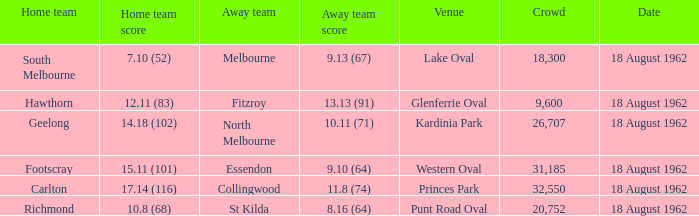Would you mind parsing the complete table? {'header': ['Home team', 'Home team score', 'Away team', 'Away team score', 'Venue', 'Crowd', 'Date'], 'rows': [['South Melbourne', '7.10 (52)', 'Melbourne', '9.13 (67)', 'Lake Oval', '18,300', '18 August 1962'], ['Hawthorn', '12.11 (83)', 'Fitzroy', '13.13 (91)', 'Glenferrie Oval', '9,600', '18 August 1962'], ['Geelong', '14.18 (102)', 'North Melbourne', '10.11 (71)', 'Kardinia Park', '26,707', '18 August 1962'], ['Footscray', '15.11 (101)', 'Essendon', '9.10 (64)', 'Western Oval', '31,185', '18 August 1962'], ['Carlton', '17.14 (116)', 'Collingwood', '11.8 (74)', 'Princes Park', '32,550', '18 August 1962'], ['Richmond', '10.8 (68)', 'St Kilda', '8.16 (64)', 'Punt Road Oval', '20,752', '18 August 1962']]} What was the away team when the home team scored 10.8 (68)? St Kilda. 